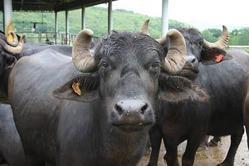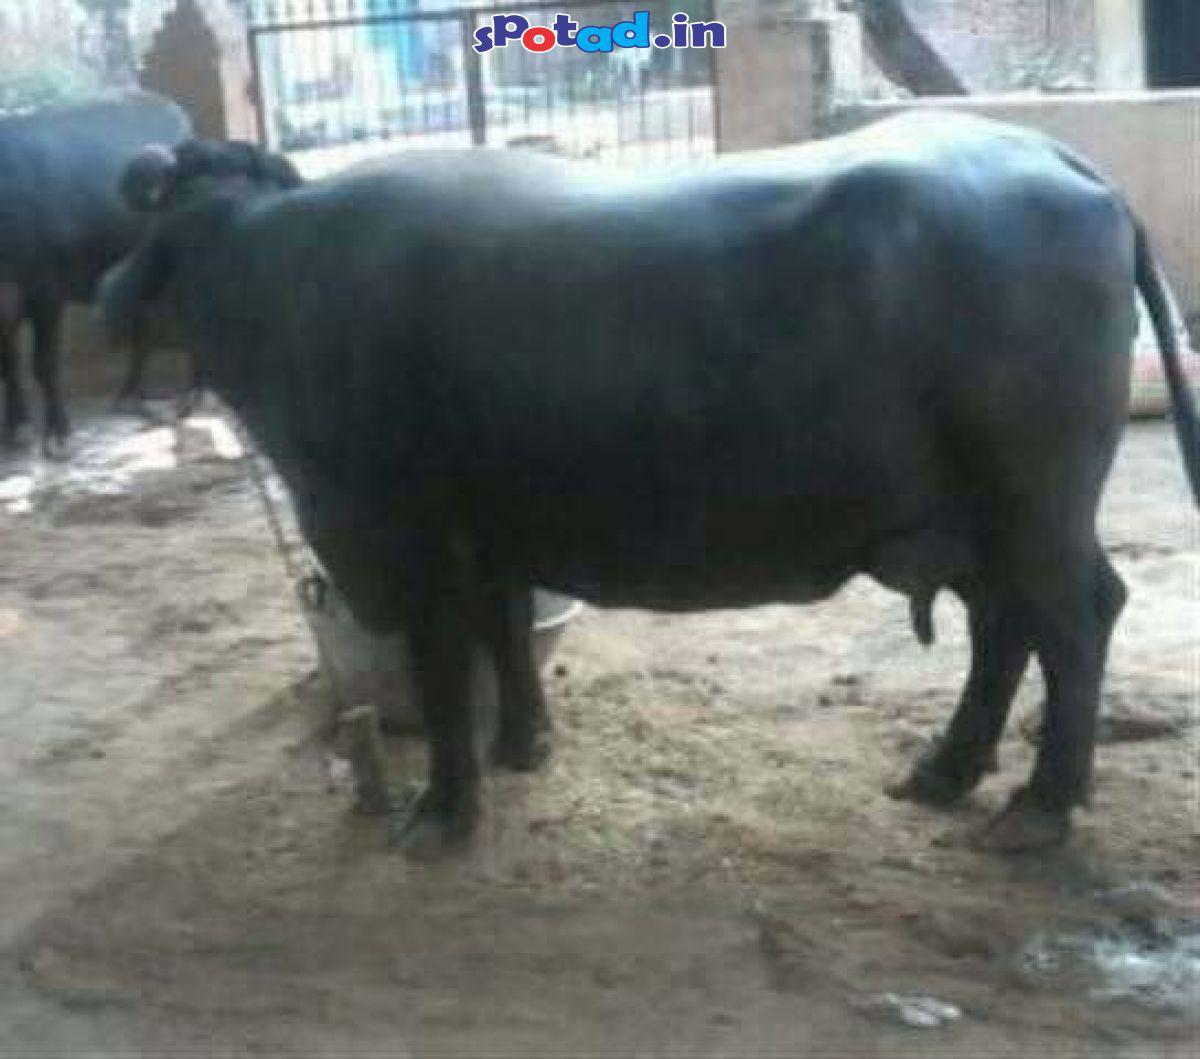The first image is the image on the left, the second image is the image on the right. For the images shown, is this caption "One image shows cattle standing facing forward on dirt ground, with columns holding up a roof in the background but no people present." true? Answer yes or no. Yes. The first image is the image on the left, the second image is the image on the right. For the images shown, is this caption "A crowd of people and cows gather together in a dirt surfaced area." true? Answer yes or no. No. 